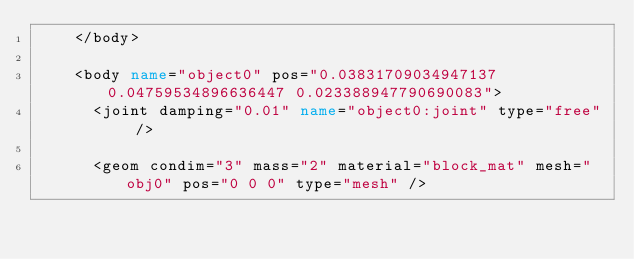<code> <loc_0><loc_0><loc_500><loc_500><_XML_>		</body>

		<body name="object0" pos="0.03831709034947137 0.04759534896636447 0.023388947790690083">
			<joint damping="0.01" name="object0:joint" type="free" />
			
			<geom condim="3" mass="2" material="block_mat" mesh="obj0" pos="0 0 0" type="mesh" />
			
			</code> 